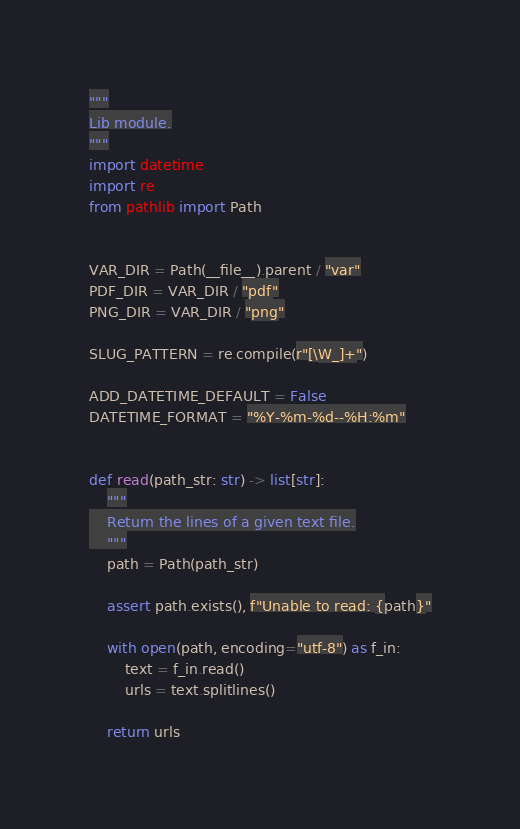<code> <loc_0><loc_0><loc_500><loc_500><_Python_>"""
Lib module.
"""
import datetime
import re
from pathlib import Path


VAR_DIR = Path(__file__).parent / "var"
PDF_DIR = VAR_DIR / "pdf"
PNG_DIR = VAR_DIR / "png"

SLUG_PATTERN = re.compile(r"[\W_]+")

ADD_DATETIME_DEFAULT = False
DATETIME_FORMAT = "%Y-%m-%d--%H:%m"


def read(path_str: str) -> list[str]:
    """
    Return the lines of a given text file.
    """
    path = Path(path_str)

    assert path.exists(), f"Unable to read: {path}"

    with open(path, encoding="utf-8") as f_in:
        text = f_in.read()
        urls = text.splitlines()

    return urls

</code> 